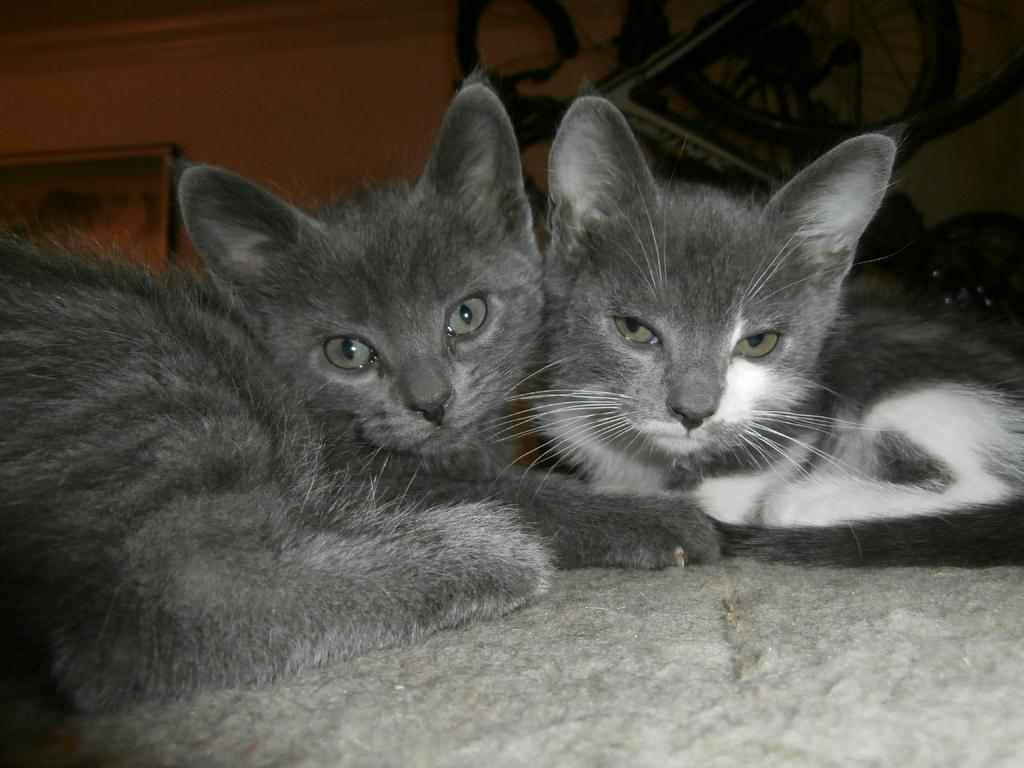What animals are lying in the image? There are two cats lying in the image. What object is visible behind the cats? There is a bicycle behind the cats. What type of structure is present in the image? There is a wall in the image. What type of dinosaurs can be seen roaming near the cats in the image? There are no dinosaurs present in the image; it features two cats lying down. What emotion is being expressed by the cats in the image? The cats' emotions cannot be determined from the image, as they are lying down and not expressing any specific emotion. 